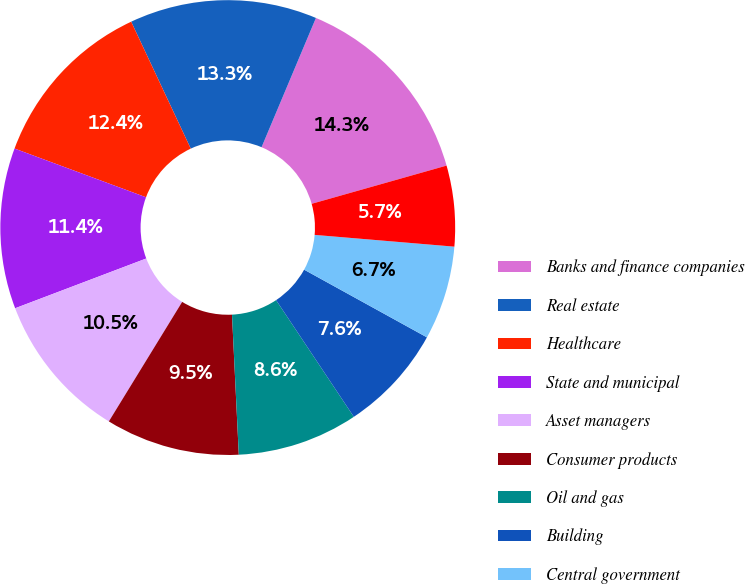Convert chart to OTSL. <chart><loc_0><loc_0><loc_500><loc_500><pie_chart><fcel>Banks and finance companies<fcel>Real estate<fcel>Healthcare<fcel>State and municipal<fcel>Asset managers<fcel>Consumer products<fcel>Oil and gas<fcel>Building<fcel>Central government<fcel>Insurance<nl><fcel>14.27%<fcel>13.32%<fcel>12.37%<fcel>11.42%<fcel>10.47%<fcel>9.53%<fcel>8.58%<fcel>7.63%<fcel>6.68%<fcel>5.73%<nl></chart> 